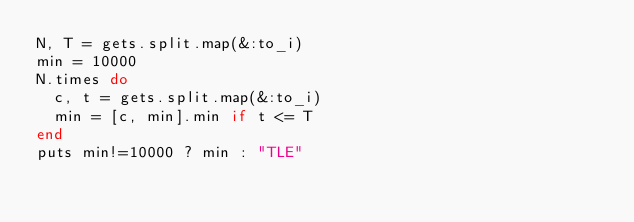Convert code to text. <code><loc_0><loc_0><loc_500><loc_500><_Ruby_>N, T = gets.split.map(&:to_i)
min = 10000
N.times do
  c, t = gets.split.map(&:to_i)
  min = [c, min].min if t <= T
end
puts min!=10000 ? min : "TLE"</code> 